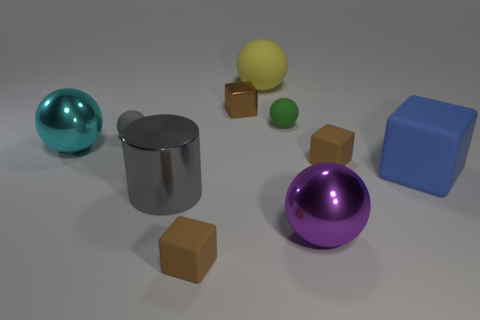Subtract all brown cubes. How many were subtracted if there are1brown cubes left? 2 Subtract all small brown shiny blocks. How many blocks are left? 3 Subtract all red spheres. How many brown cubes are left? 3 Subtract all cubes. How many objects are left? 6 Subtract all purple spheres. How many spheres are left? 4 Subtract 1 yellow balls. How many objects are left? 9 Subtract 1 cylinders. How many cylinders are left? 0 Subtract all purple spheres. Subtract all gray cylinders. How many spheres are left? 4 Subtract all tiny shiny blocks. Subtract all large cyan shiny balls. How many objects are left? 8 Add 5 small matte objects. How many small matte objects are left? 9 